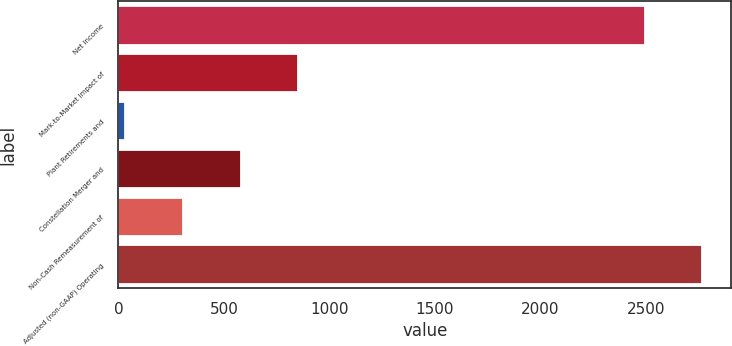Convert chart. <chart><loc_0><loc_0><loc_500><loc_500><bar_chart><fcel>Net Income<fcel>Mark-to-Market Impact of<fcel>Plant Retirements and<fcel>Constellation Merger and<fcel>Non-Cash Remeasurement of<fcel>Adjusted (non-GAAP) Operating<nl><fcel>2495<fcel>852<fcel>33<fcel>579<fcel>306<fcel>2768<nl></chart> 